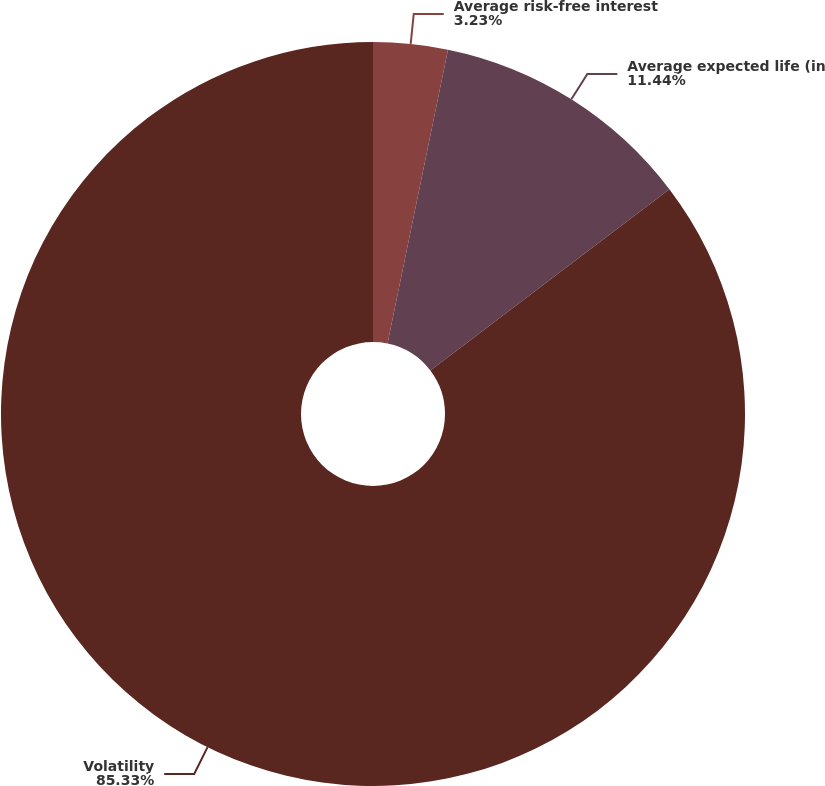Convert chart to OTSL. <chart><loc_0><loc_0><loc_500><loc_500><pie_chart><fcel>Average risk-free interest<fcel>Average expected life (in<fcel>Volatility<nl><fcel>3.23%<fcel>11.44%<fcel>85.32%<nl></chart> 